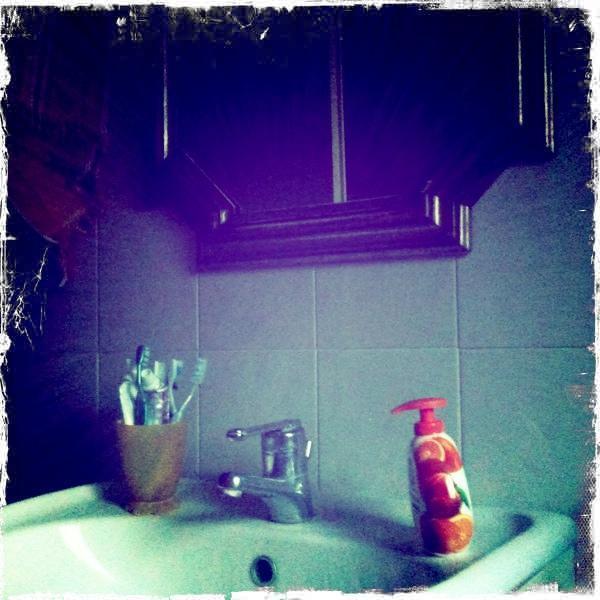How many people are wearing red pants?
Give a very brief answer. 0. 